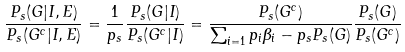Convert formula to latex. <formula><loc_0><loc_0><loc_500><loc_500>\frac { P _ { s } ( G | I , E ) } { P _ { s } ( G ^ { c } | I , E ) } = \frac { 1 } { p _ { s } } \frac { P _ { s } ( G | I ) } { P _ { s } ( G ^ { c } | I ) } = \frac { P _ { s } ( G ^ { c } ) } { \sum _ { i = 1 } p _ { i } \beta _ { i } - p _ { s } P _ { s } ( G ) } \frac { P _ { s } ( G ) } { P _ { s } ( G ^ { c } ) }</formula> 